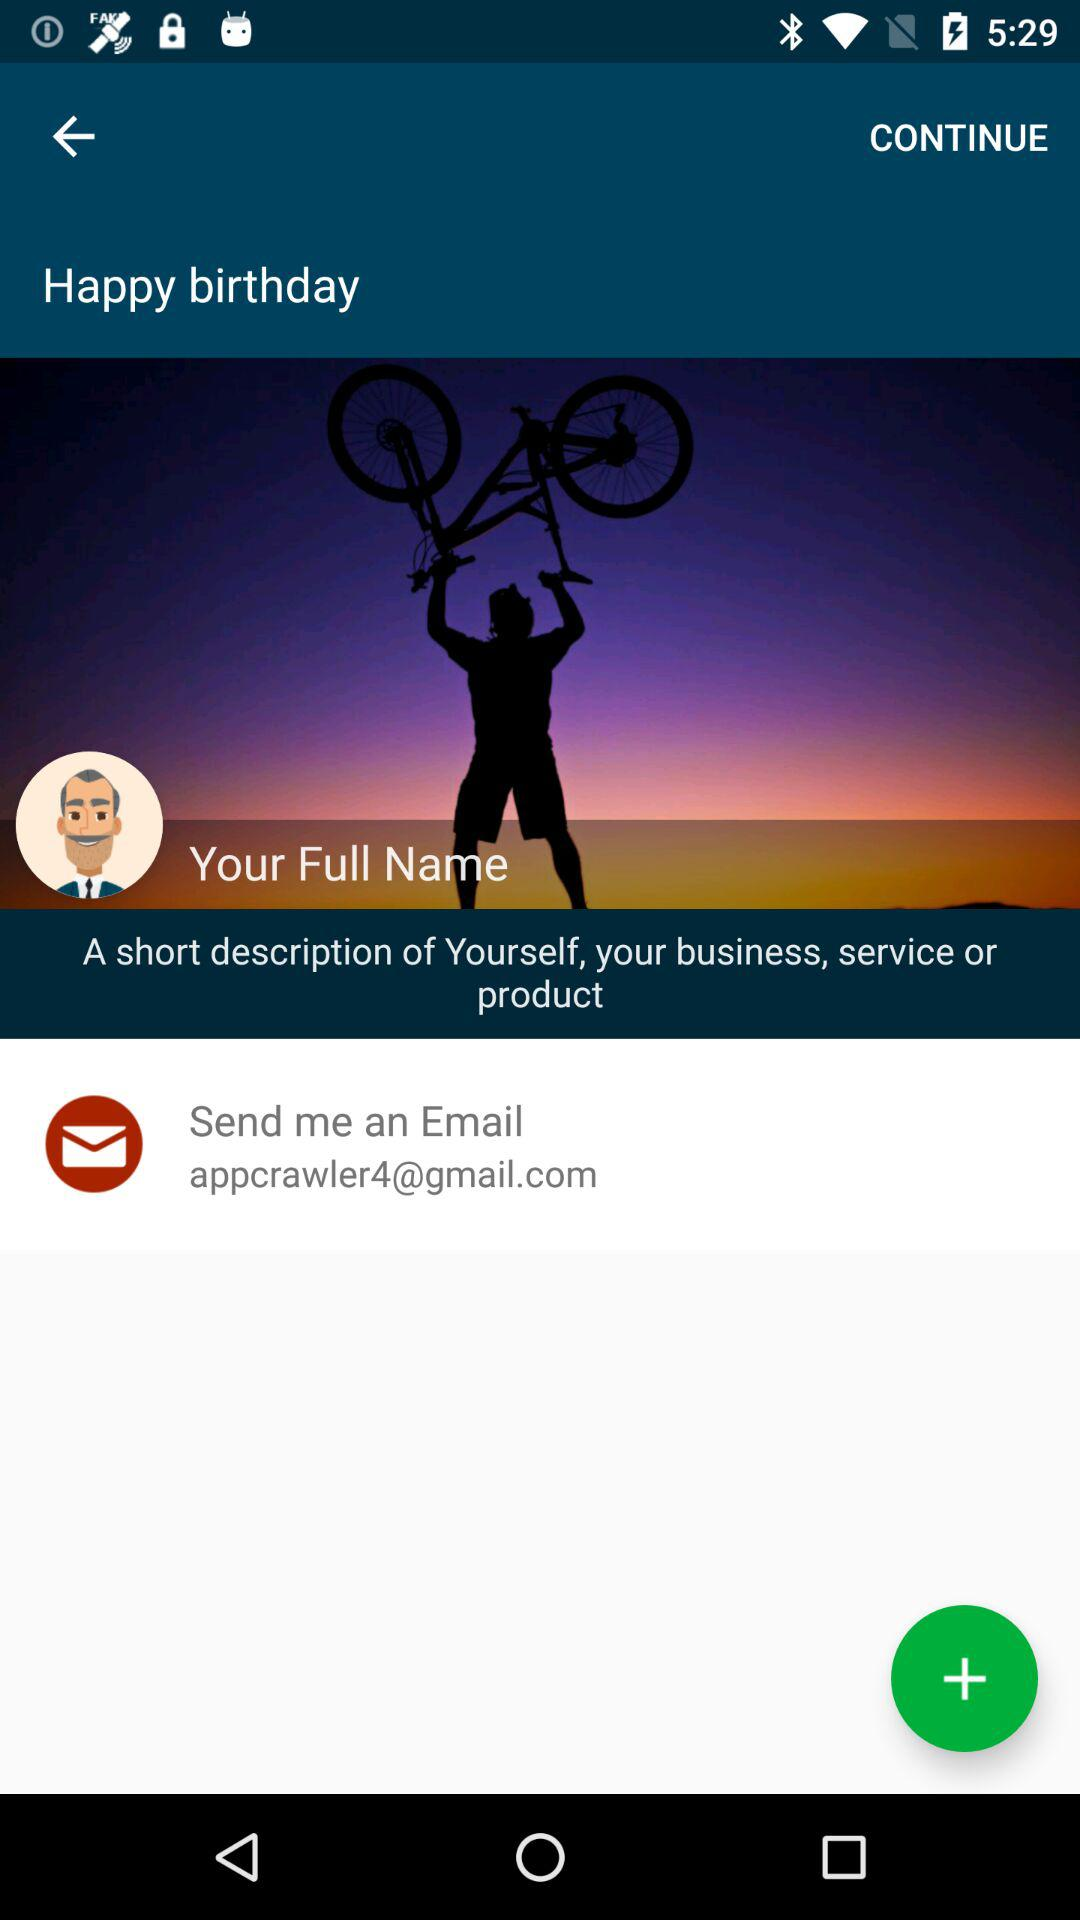What is the given email address? The email address is "appcrawler4@gmail.com". 